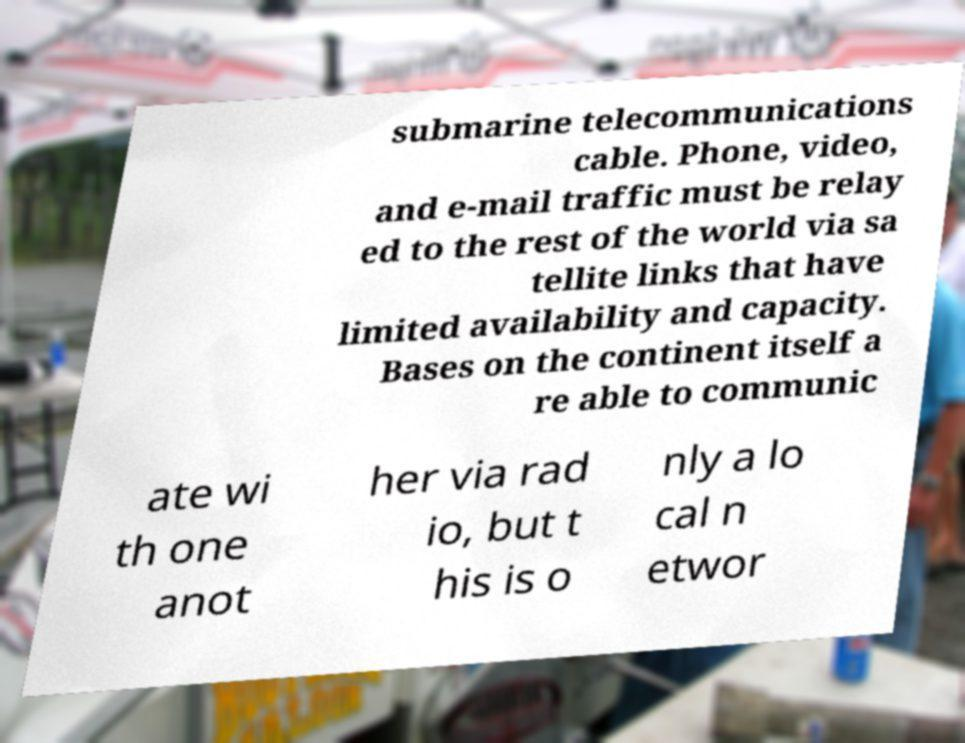Can you read and provide the text displayed in the image?This photo seems to have some interesting text. Can you extract and type it out for me? submarine telecommunications cable. Phone, video, and e-mail traffic must be relay ed to the rest of the world via sa tellite links that have limited availability and capacity. Bases on the continent itself a re able to communic ate wi th one anot her via rad io, but t his is o nly a lo cal n etwor 